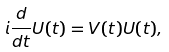<formula> <loc_0><loc_0><loc_500><loc_500>i \frac { d } { d t } U ( t ) = V ( t ) U ( t ) ,</formula> 